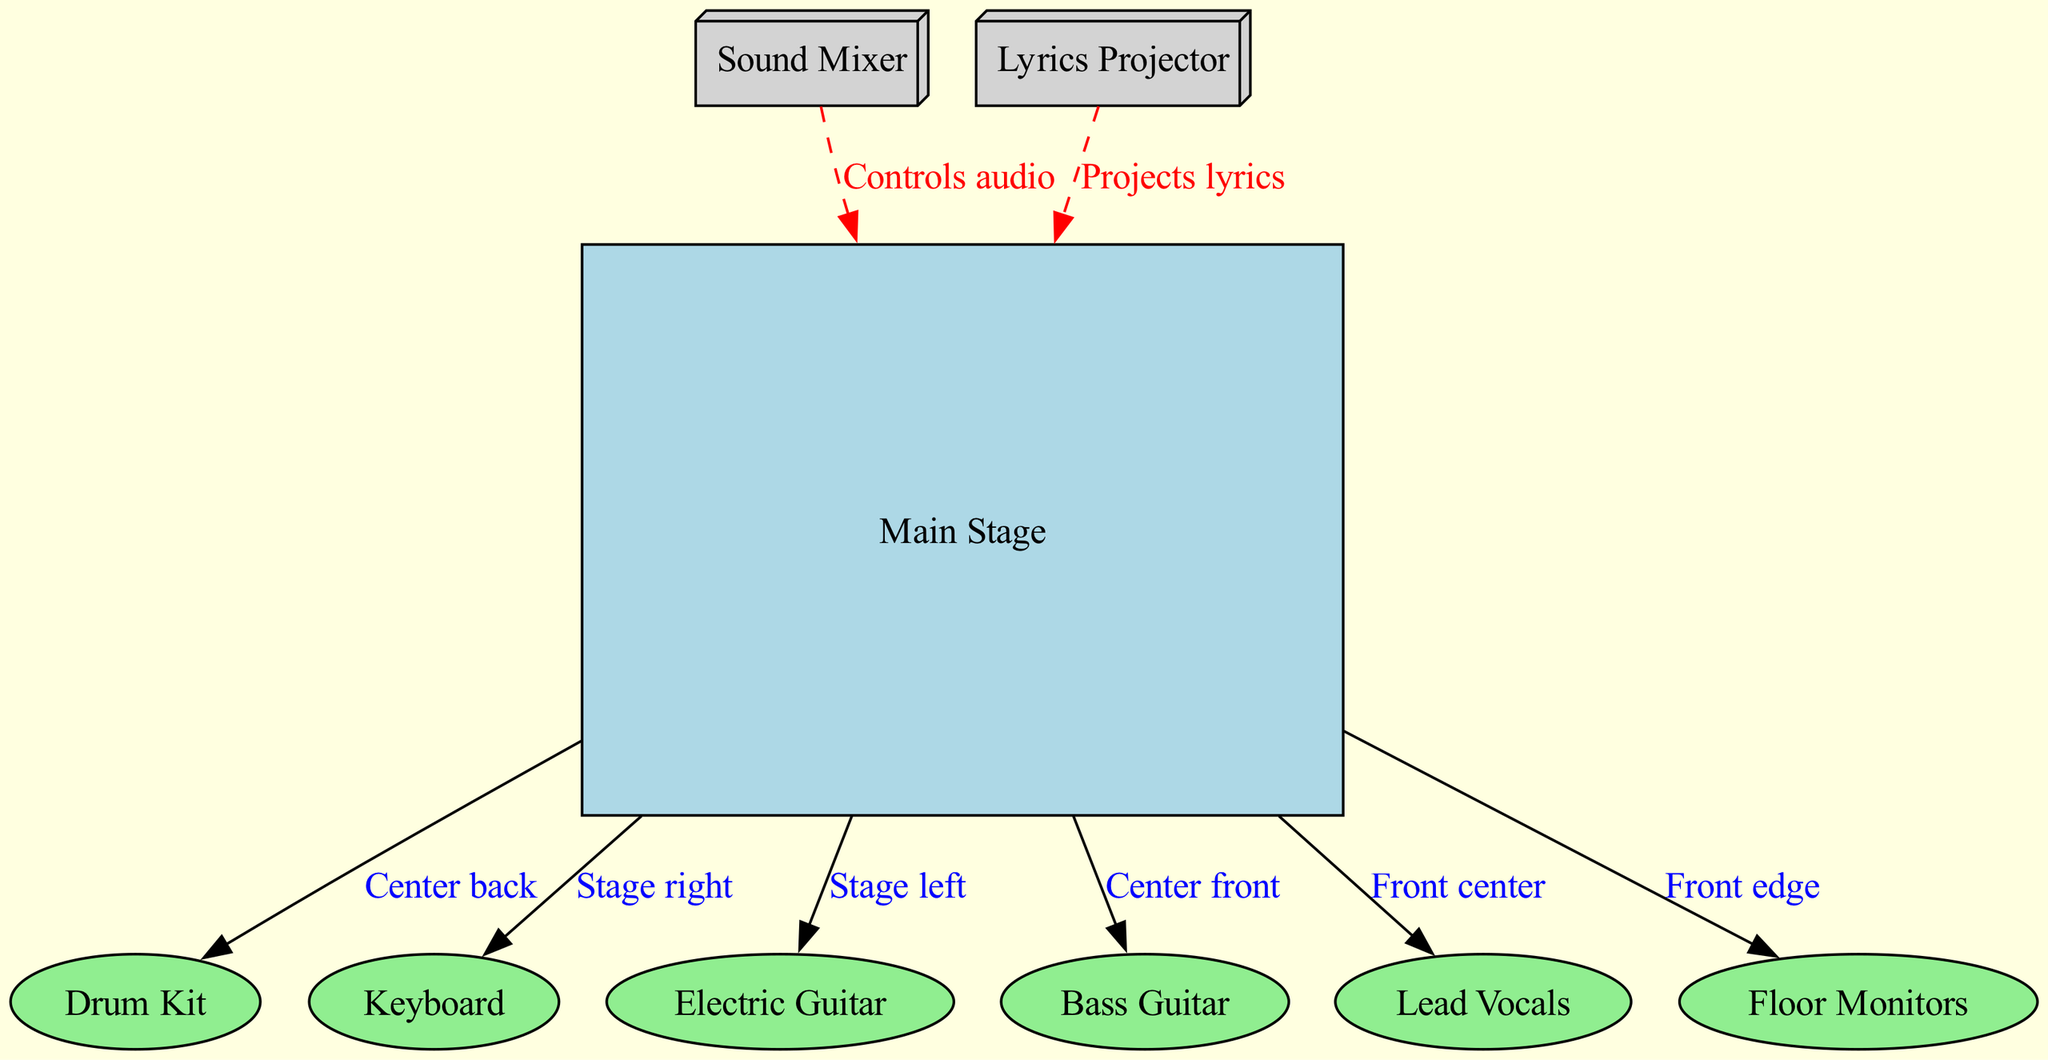What is the role of the mixer in the setup? The mixer is represented in the diagram as a node labeled "Sound Mixer". It indicates the device responsible for controlling audio from different sources on the stage. Its connection to the stage suggests it plays a central role in audio management during performances.
Answer: Controls audio Where is the drum kit placed in relation to the stage? The diagram shows that the drum kit is connected to the stage with the label "Center back." This indicates that the drum kit is positioned towards the back center of the stage area.
Answer: Center back How many nodes are present in the diagram? Counting the distinct nodes listed reveals a total of nine: Main Stage, Drum Kit, Keyboard, Electric Guitar, Bass Guitar, Lead Vocals, Floor Monitors, Sound Mixer, and Lyrics Projector.
Answer: Nine What is the position of the lead vocals relative to the stage? The lead vocals node connects to the stage with the label "Front center." This indicates that the lead vocals are positioned at the center front of the stage during performances.
Answer: Front center What is the purpose of the lyrics projector? The lyrics projector is represented in the diagram as a node labeled "Lyrics Projector". It is designed to project song lyrics onto a screen or surface for the audience, facilitating congregational participation in worship.
Answer: Projects lyrics Where is the bass guitar located on the stage? The bass guitar is connected to the stage with the label "Center front." This shows that the bass guitar is located at the front center of the stage, emphasizing its importance in the worship band setup.
Answer: Center front How does the projector connect with the stage? The projector connects to the stage with the label "Projects lyrics," indicating its function in displaying lyrics and its position is essential for audience engagement. This relationship suggests the projector's visual role complements the audio elements presented by the stage.
Answer: Projects lyrics What type of connection exists between the mixer and the stage? The connection between the mixer and the stage is marked with a dashed line labeled "Controls audio." This indicates it's a management connection rather than a direct performance connection, emphasizing its role in overseeing the audio mix during the worship session.
Answer: Controls audio Where are the monitors located in relation to the front of the stage? In the diagram, the monitors are connected to the stage with the label "Front edge," indicating their placement at the front edge of the stage, which is crucial for the performers to hear themselves and each other during the performance.
Answer: Front edge 